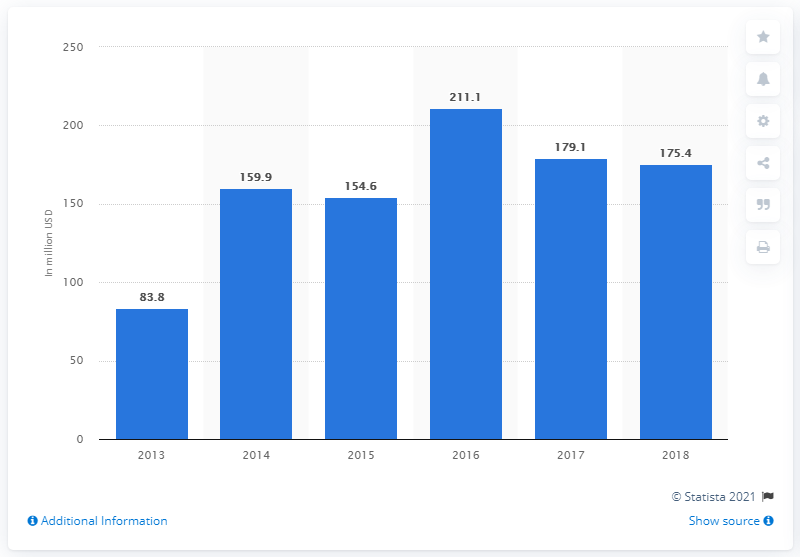What was the total transaction value of reward-based crowdfunding in the United States in 2018? In 2018, the total transaction value of reward-based crowdfunding in the United States reached $175.4 million, reflecting a slight decrease from the previous year's peak of $179.1 million. This trend was visualized in a bar chart, which provided a clear overview of the crowdfunding dynamics over the years, with a notable growth trajectory starting from $83.8 million in 2013. 